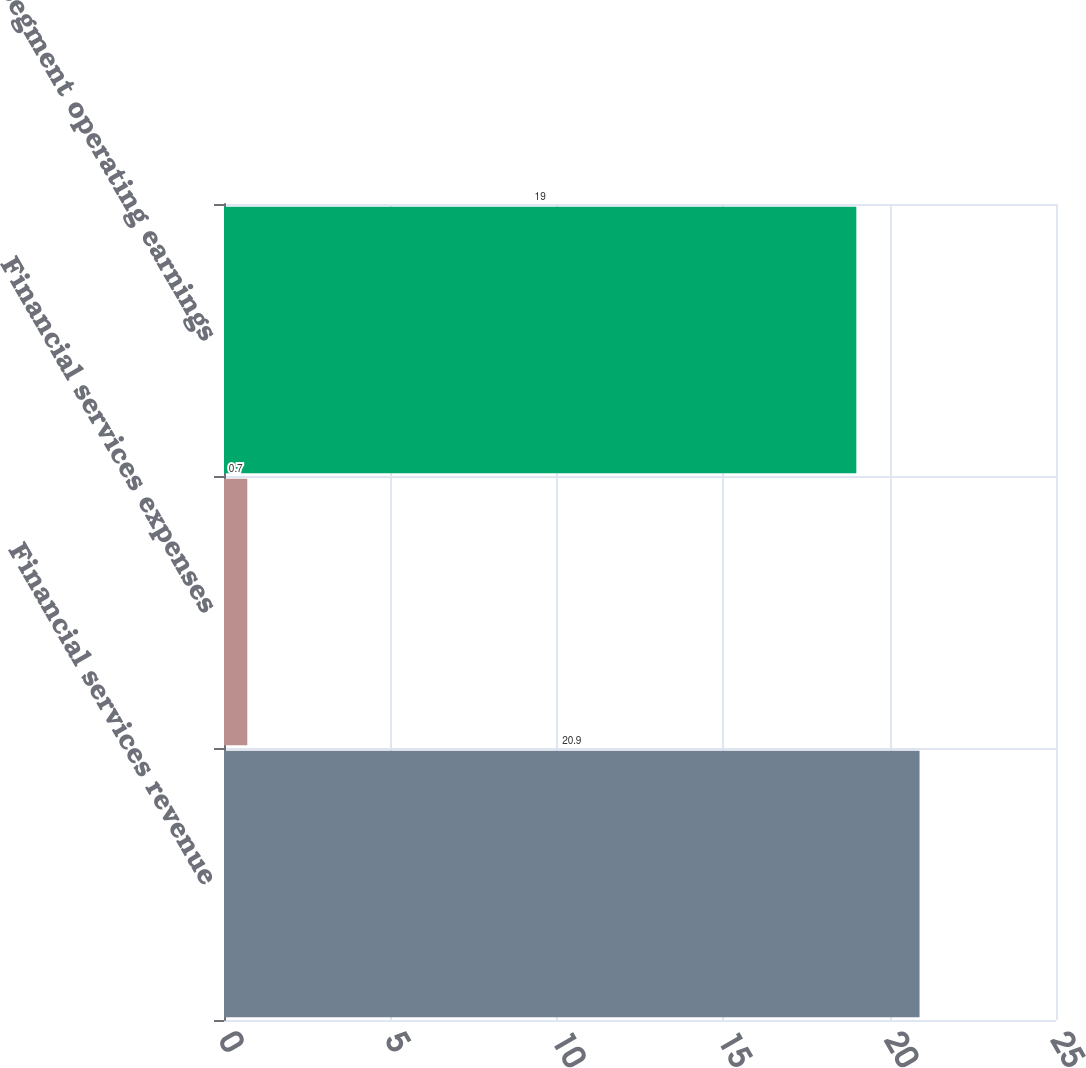Convert chart to OTSL. <chart><loc_0><loc_0><loc_500><loc_500><bar_chart><fcel>Financial services revenue<fcel>Financial services expenses<fcel>Segment operating earnings<nl><fcel>20.9<fcel>0.7<fcel>19<nl></chart> 